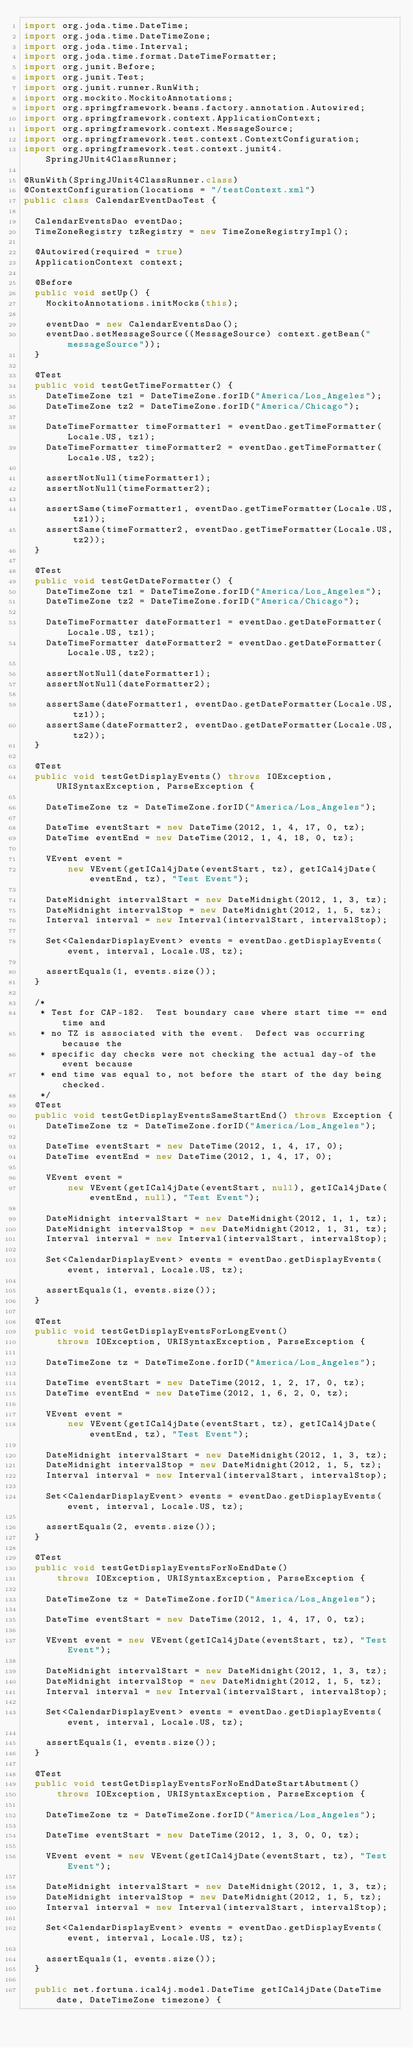Convert code to text. <code><loc_0><loc_0><loc_500><loc_500><_Java_>import org.joda.time.DateTime;
import org.joda.time.DateTimeZone;
import org.joda.time.Interval;
import org.joda.time.format.DateTimeFormatter;
import org.junit.Before;
import org.junit.Test;
import org.junit.runner.RunWith;
import org.mockito.MockitoAnnotations;
import org.springframework.beans.factory.annotation.Autowired;
import org.springframework.context.ApplicationContext;
import org.springframework.context.MessageSource;
import org.springframework.test.context.ContextConfiguration;
import org.springframework.test.context.junit4.SpringJUnit4ClassRunner;

@RunWith(SpringJUnit4ClassRunner.class)
@ContextConfiguration(locations = "/testContext.xml")
public class CalendarEventDaoTest {

  CalendarEventsDao eventDao;
  TimeZoneRegistry tzRegistry = new TimeZoneRegistryImpl();

  @Autowired(required = true)
  ApplicationContext context;

  @Before
  public void setUp() {
    MockitoAnnotations.initMocks(this);

    eventDao = new CalendarEventsDao();
    eventDao.setMessageSource((MessageSource) context.getBean("messageSource"));
  }

  @Test
  public void testGetTimeFormatter() {
    DateTimeZone tz1 = DateTimeZone.forID("America/Los_Angeles");
    DateTimeZone tz2 = DateTimeZone.forID("America/Chicago");

    DateTimeFormatter timeFormatter1 = eventDao.getTimeFormatter(Locale.US, tz1);
    DateTimeFormatter timeFormatter2 = eventDao.getTimeFormatter(Locale.US, tz2);

    assertNotNull(timeFormatter1);
    assertNotNull(timeFormatter2);

    assertSame(timeFormatter1, eventDao.getTimeFormatter(Locale.US, tz1));
    assertSame(timeFormatter2, eventDao.getTimeFormatter(Locale.US, tz2));
  }

  @Test
  public void testGetDateFormatter() {
    DateTimeZone tz1 = DateTimeZone.forID("America/Los_Angeles");
    DateTimeZone tz2 = DateTimeZone.forID("America/Chicago");

    DateTimeFormatter dateFormatter1 = eventDao.getDateFormatter(Locale.US, tz1);
    DateTimeFormatter dateFormatter2 = eventDao.getDateFormatter(Locale.US, tz2);

    assertNotNull(dateFormatter1);
    assertNotNull(dateFormatter2);

    assertSame(dateFormatter1, eventDao.getDateFormatter(Locale.US, tz1));
    assertSame(dateFormatter2, eventDao.getDateFormatter(Locale.US, tz2));
  }

  @Test
  public void testGetDisplayEvents() throws IOException, URISyntaxException, ParseException {

    DateTimeZone tz = DateTimeZone.forID("America/Los_Angeles");

    DateTime eventStart = new DateTime(2012, 1, 4, 17, 0, tz);
    DateTime eventEnd = new DateTime(2012, 1, 4, 18, 0, tz);

    VEvent event =
        new VEvent(getICal4jDate(eventStart, tz), getICal4jDate(eventEnd, tz), "Test Event");

    DateMidnight intervalStart = new DateMidnight(2012, 1, 3, tz);
    DateMidnight intervalStop = new DateMidnight(2012, 1, 5, tz);
    Interval interval = new Interval(intervalStart, intervalStop);

    Set<CalendarDisplayEvent> events = eventDao.getDisplayEvents(event, interval, Locale.US, tz);

    assertEquals(1, events.size());
  }

  /*
   * Test for CAP-182.  Test boundary case where start time == end time and
   * no TZ is associated with the event.  Defect was occurring because the
   * specific day checks were not checking the actual day-of the event because
   * end time was equal to, not before the start of the day being checked.
   */
  @Test
  public void testGetDisplayEventsSameStartEnd() throws Exception {
    DateTimeZone tz = DateTimeZone.forID("America/Los_Angeles");

    DateTime eventStart = new DateTime(2012, 1, 4, 17, 0);
    DateTime eventEnd = new DateTime(2012, 1, 4, 17, 0);

    VEvent event =
        new VEvent(getICal4jDate(eventStart, null), getICal4jDate(eventEnd, null), "Test Event");

    DateMidnight intervalStart = new DateMidnight(2012, 1, 1, tz);
    DateMidnight intervalStop = new DateMidnight(2012, 1, 31, tz);
    Interval interval = new Interval(intervalStart, intervalStop);

    Set<CalendarDisplayEvent> events = eventDao.getDisplayEvents(event, interval, Locale.US, tz);

    assertEquals(1, events.size());
  }

  @Test
  public void testGetDisplayEventsForLongEvent()
      throws IOException, URISyntaxException, ParseException {

    DateTimeZone tz = DateTimeZone.forID("America/Los_Angeles");

    DateTime eventStart = new DateTime(2012, 1, 2, 17, 0, tz);
    DateTime eventEnd = new DateTime(2012, 1, 6, 2, 0, tz);

    VEvent event =
        new VEvent(getICal4jDate(eventStart, tz), getICal4jDate(eventEnd, tz), "Test Event");

    DateMidnight intervalStart = new DateMidnight(2012, 1, 3, tz);
    DateMidnight intervalStop = new DateMidnight(2012, 1, 5, tz);
    Interval interval = new Interval(intervalStart, intervalStop);

    Set<CalendarDisplayEvent> events = eventDao.getDisplayEvents(event, interval, Locale.US, tz);

    assertEquals(2, events.size());
  }

  @Test
  public void testGetDisplayEventsForNoEndDate()
      throws IOException, URISyntaxException, ParseException {

    DateTimeZone tz = DateTimeZone.forID("America/Los_Angeles");

    DateTime eventStart = new DateTime(2012, 1, 4, 17, 0, tz);

    VEvent event = new VEvent(getICal4jDate(eventStart, tz), "Test Event");

    DateMidnight intervalStart = new DateMidnight(2012, 1, 3, tz);
    DateMidnight intervalStop = new DateMidnight(2012, 1, 5, tz);
    Interval interval = new Interval(intervalStart, intervalStop);

    Set<CalendarDisplayEvent> events = eventDao.getDisplayEvents(event, interval, Locale.US, tz);

    assertEquals(1, events.size());
  }

  @Test
  public void testGetDisplayEventsForNoEndDateStartAbutment()
      throws IOException, URISyntaxException, ParseException {

    DateTimeZone tz = DateTimeZone.forID("America/Los_Angeles");

    DateTime eventStart = new DateTime(2012, 1, 3, 0, 0, tz);

    VEvent event = new VEvent(getICal4jDate(eventStart, tz), "Test Event");

    DateMidnight intervalStart = new DateMidnight(2012, 1, 3, tz);
    DateMidnight intervalStop = new DateMidnight(2012, 1, 5, tz);
    Interval interval = new Interval(intervalStart, intervalStop);

    Set<CalendarDisplayEvent> events = eventDao.getDisplayEvents(event, interval, Locale.US, tz);

    assertEquals(1, events.size());
  }

  public net.fortuna.ical4j.model.DateTime getICal4jDate(DateTime date, DateTimeZone timezone) {</code> 